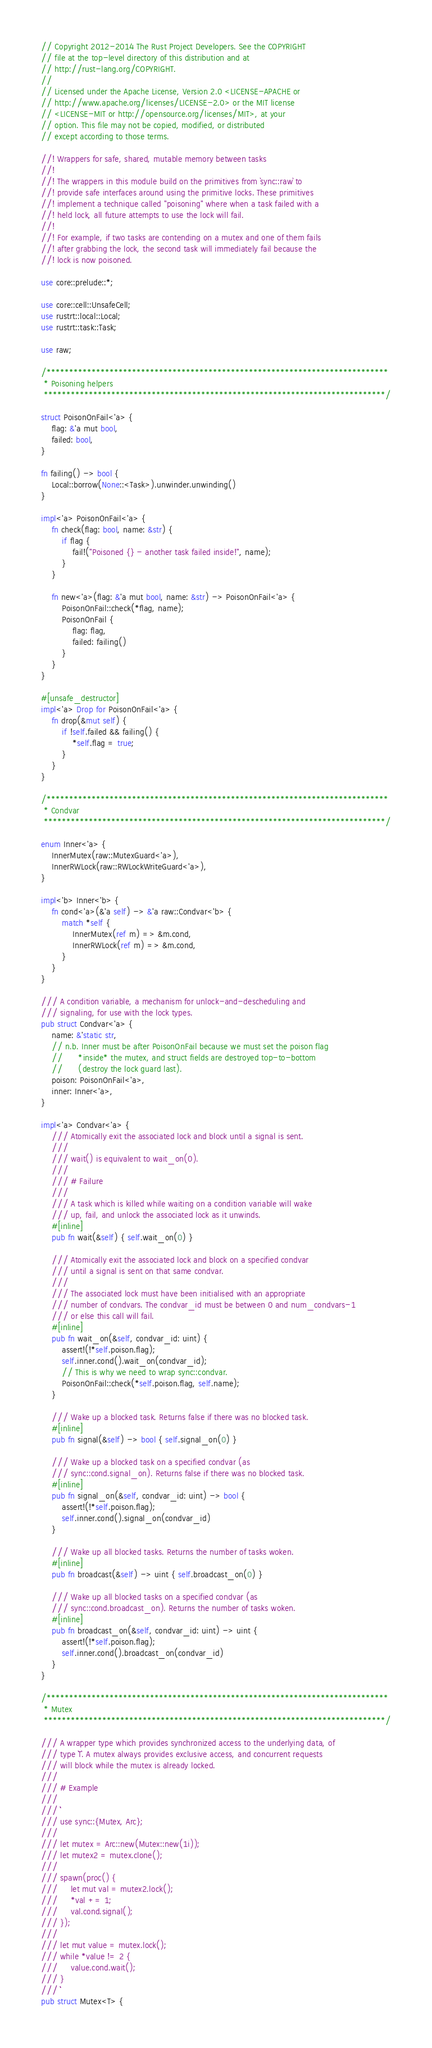Convert code to text. <code><loc_0><loc_0><loc_500><loc_500><_Rust_>// Copyright 2012-2014 The Rust Project Developers. See the COPYRIGHT
// file at the top-level directory of this distribution and at
// http://rust-lang.org/COPYRIGHT.
//
// Licensed under the Apache License, Version 2.0 <LICENSE-APACHE or
// http://www.apache.org/licenses/LICENSE-2.0> or the MIT license
// <LICENSE-MIT or http://opensource.org/licenses/MIT>, at your
// option. This file may not be copied, modified, or distributed
// except according to those terms.

//! Wrappers for safe, shared, mutable memory between tasks
//!
//! The wrappers in this module build on the primitives from `sync::raw` to
//! provide safe interfaces around using the primitive locks. These primitives
//! implement a technique called "poisoning" where when a task failed with a
//! held lock, all future attempts to use the lock will fail.
//!
//! For example, if two tasks are contending on a mutex and one of them fails
//! after grabbing the lock, the second task will immediately fail because the
//! lock is now poisoned.

use core::prelude::*;

use core::cell::UnsafeCell;
use rustrt::local::Local;
use rustrt::task::Task;

use raw;

/****************************************************************************
 * Poisoning helpers
 ****************************************************************************/

struct PoisonOnFail<'a> {
    flag: &'a mut bool,
    failed: bool,
}

fn failing() -> bool {
    Local::borrow(None::<Task>).unwinder.unwinding()
}

impl<'a> PoisonOnFail<'a> {
    fn check(flag: bool, name: &str) {
        if flag {
            fail!("Poisoned {} - another task failed inside!", name);
        }
    }

    fn new<'a>(flag: &'a mut bool, name: &str) -> PoisonOnFail<'a> {
        PoisonOnFail::check(*flag, name);
        PoisonOnFail {
            flag: flag,
            failed: failing()
        }
    }
}

#[unsafe_destructor]
impl<'a> Drop for PoisonOnFail<'a> {
    fn drop(&mut self) {
        if !self.failed && failing() {
            *self.flag = true;
        }
    }
}

/****************************************************************************
 * Condvar
 ****************************************************************************/

enum Inner<'a> {
    InnerMutex(raw::MutexGuard<'a>),
    InnerRWLock(raw::RWLockWriteGuard<'a>),
}

impl<'b> Inner<'b> {
    fn cond<'a>(&'a self) -> &'a raw::Condvar<'b> {
        match *self {
            InnerMutex(ref m) => &m.cond,
            InnerRWLock(ref m) => &m.cond,
        }
    }
}

/// A condition variable, a mechanism for unlock-and-descheduling and
/// signaling, for use with the lock types.
pub struct Condvar<'a> {
    name: &'static str,
    // n.b. Inner must be after PoisonOnFail because we must set the poison flag
    //      *inside* the mutex, and struct fields are destroyed top-to-bottom
    //      (destroy the lock guard last).
    poison: PoisonOnFail<'a>,
    inner: Inner<'a>,
}

impl<'a> Condvar<'a> {
    /// Atomically exit the associated lock and block until a signal is sent.
    ///
    /// wait() is equivalent to wait_on(0).
    ///
    /// # Failure
    ///
    /// A task which is killed while waiting on a condition variable will wake
    /// up, fail, and unlock the associated lock as it unwinds.
    #[inline]
    pub fn wait(&self) { self.wait_on(0) }

    /// Atomically exit the associated lock and block on a specified condvar
    /// until a signal is sent on that same condvar.
    ///
    /// The associated lock must have been initialised with an appropriate
    /// number of condvars. The condvar_id must be between 0 and num_condvars-1
    /// or else this call will fail.
    #[inline]
    pub fn wait_on(&self, condvar_id: uint) {
        assert!(!*self.poison.flag);
        self.inner.cond().wait_on(condvar_id);
        // This is why we need to wrap sync::condvar.
        PoisonOnFail::check(*self.poison.flag, self.name);
    }

    /// Wake up a blocked task. Returns false if there was no blocked task.
    #[inline]
    pub fn signal(&self) -> bool { self.signal_on(0) }

    /// Wake up a blocked task on a specified condvar (as
    /// sync::cond.signal_on). Returns false if there was no blocked task.
    #[inline]
    pub fn signal_on(&self, condvar_id: uint) -> bool {
        assert!(!*self.poison.flag);
        self.inner.cond().signal_on(condvar_id)
    }

    /// Wake up all blocked tasks. Returns the number of tasks woken.
    #[inline]
    pub fn broadcast(&self) -> uint { self.broadcast_on(0) }

    /// Wake up all blocked tasks on a specified condvar (as
    /// sync::cond.broadcast_on). Returns the number of tasks woken.
    #[inline]
    pub fn broadcast_on(&self, condvar_id: uint) -> uint {
        assert!(!*self.poison.flag);
        self.inner.cond().broadcast_on(condvar_id)
    }
}

/****************************************************************************
 * Mutex
 ****************************************************************************/

/// A wrapper type which provides synchronized access to the underlying data, of
/// type `T`. A mutex always provides exclusive access, and concurrent requests
/// will block while the mutex is already locked.
///
/// # Example
///
/// ```
/// use sync::{Mutex, Arc};
///
/// let mutex = Arc::new(Mutex::new(1i));
/// let mutex2 = mutex.clone();
///
/// spawn(proc() {
///     let mut val = mutex2.lock();
///     *val += 1;
///     val.cond.signal();
/// });
///
/// let mut value = mutex.lock();
/// while *value != 2 {
///     value.cond.wait();
/// }
/// ```
pub struct Mutex<T> {</code> 